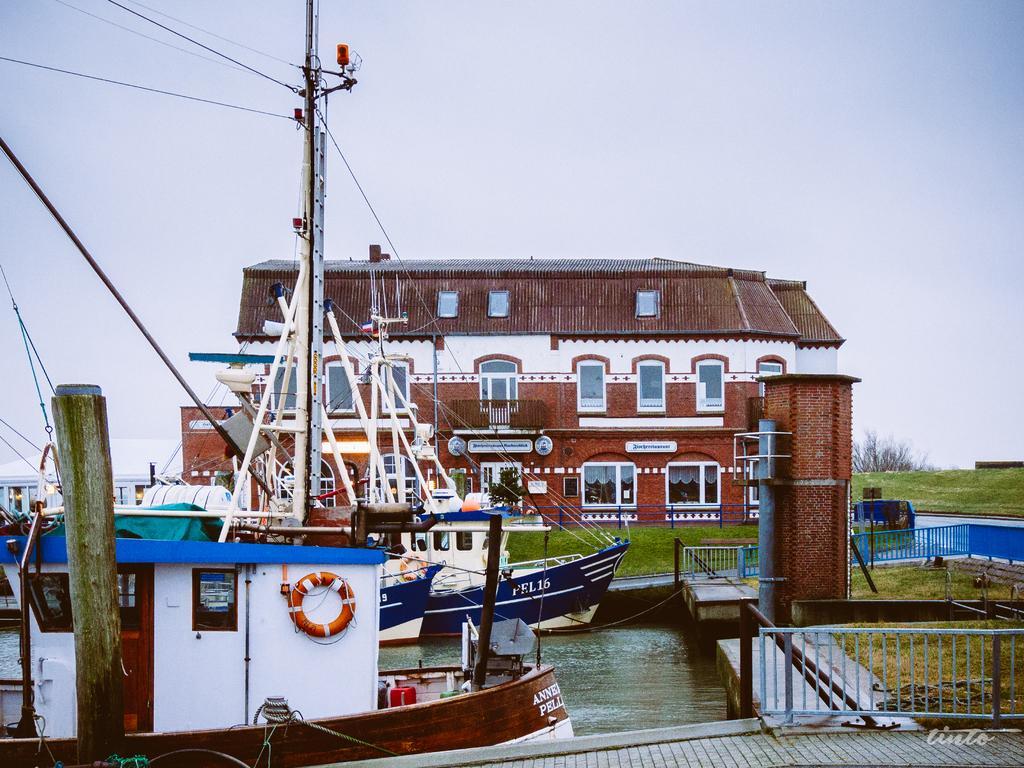In one or two sentences, can you explain what this image depicts? In the picture I can see few boats on the water and there is a building and a greenery ground in the background. 